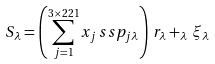<formula> <loc_0><loc_0><loc_500><loc_500>S _ { \lambda } = \left ( \sum _ { j = 1 } ^ { 3 \times 2 2 1 } x _ { j } \, s s p _ { j \lambda } \right ) \, r _ { \lambda } + _ { \lambda } \, \xi _ { \lambda }</formula> 